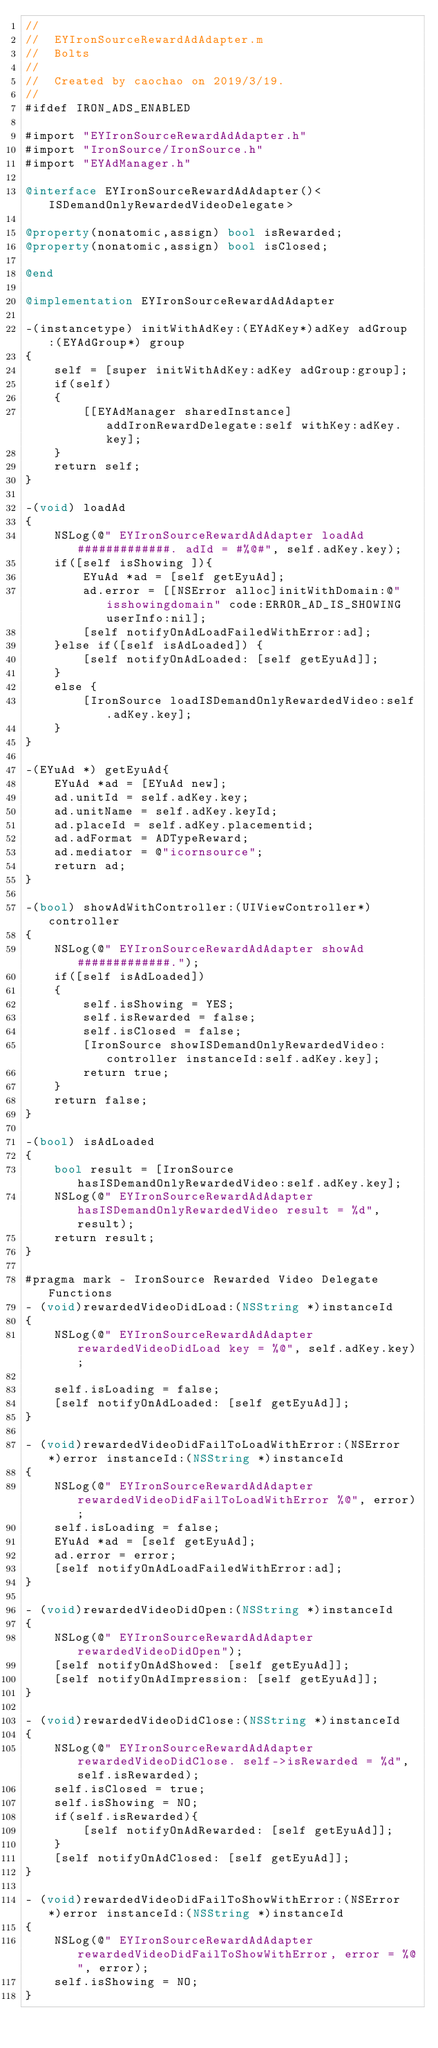<code> <loc_0><loc_0><loc_500><loc_500><_ObjectiveC_>//
//  EYIronSourceRewardAdAdapter.m
//  Bolts
//
//  Created by caochao on 2019/3/19.
//
#ifdef IRON_ADS_ENABLED

#import "EYIronSourceRewardAdAdapter.h"
#import "IronSource/IronSource.h"
#import "EYAdManager.h"

@interface EYIronSourceRewardAdAdapter()<ISDemandOnlyRewardedVideoDelegate>

@property(nonatomic,assign) bool isRewarded;
@property(nonatomic,assign) bool isClosed;

@end

@implementation EYIronSourceRewardAdAdapter

-(instancetype) initWithAdKey:(EYAdKey*)adKey adGroup:(EYAdGroup*) group
{
    self = [super initWithAdKey:adKey adGroup:group];
    if(self)
    {
        [[EYAdManager sharedInstance] addIronRewardDelegate:self withKey:adKey.key];
    }
    return self;
}

-(void) loadAd
{
    NSLog(@" EYIronSourceRewardAdAdapter loadAd #############. adId = #%@#", self.adKey.key);
    if([self isShowing ]){
        EYuAd *ad = [self getEyuAd];
        ad.error = [[NSError alloc]initWithDomain:@"isshowingdomain" code:ERROR_AD_IS_SHOWING userInfo:nil];
        [self notifyOnAdLoadFailedWithError:ad];
    }else if([self isAdLoaded]) {
        [self notifyOnAdLoaded: [self getEyuAd]];
    }
    else {
        [IronSource loadISDemandOnlyRewardedVideo:self.adKey.key];
    }
}

-(EYuAd *) getEyuAd{
    EYuAd *ad = [EYuAd new];
    ad.unitId = self.adKey.key;
    ad.unitName = self.adKey.keyId;
    ad.placeId = self.adKey.placementid;
    ad.adFormat = ADTypeReward;
    ad.mediator = @"icornsource";
    return ad;
}

-(bool) showAdWithController:(UIViewController*) controller
{
    NSLog(@" EYIronSourceRewardAdAdapter showAd #############.");
    if([self isAdLoaded])
    {
        self.isShowing = YES;
        self.isRewarded = false;
        self.isClosed = false;
        [IronSource showISDemandOnlyRewardedVideo:controller instanceId:self.adKey.key];
        return true;
    }
    return false;
}

-(bool) isAdLoaded
{
    bool result = [IronSource hasISDemandOnlyRewardedVideo:self.adKey.key];
    NSLog(@" EYIronSourceRewardAdAdapter hasISDemandOnlyRewardedVideo result = %d",result);
    return result;
}

#pragma mark - IronSource Rewarded Video Delegate Functions
- (void)rewardedVideoDidLoad:(NSString *)instanceId
{
    NSLog(@" EYIronSourceRewardAdAdapter rewardedVideoDidLoad key = %@", self.adKey.key);

    self.isLoading = false;
    [self notifyOnAdLoaded: [self getEyuAd]];
}

- (void)rewardedVideoDidFailToLoadWithError:(NSError *)error instanceId:(NSString *)instanceId
{
    NSLog(@" EYIronSourceRewardAdAdapter rewardedVideoDidFailToLoadWithError %@", error);
    self.isLoading = false;
    EYuAd *ad = [self getEyuAd];
    ad.error = error;
    [self notifyOnAdLoadFailedWithError:ad];
}

- (void)rewardedVideoDidOpen:(NSString *)instanceId
{
    NSLog(@" EYIronSourceRewardAdAdapter rewardedVideoDidOpen");
    [self notifyOnAdShowed: [self getEyuAd]];
    [self notifyOnAdImpression: [self getEyuAd]];
}

- (void)rewardedVideoDidClose:(NSString *)instanceId
{
    NSLog(@" EYIronSourceRewardAdAdapter rewardedVideoDidClose. self->isRewarded = %d", self.isRewarded);
    self.isClosed = true;
    self.isShowing = NO;
    if(self.isRewarded){
        [self notifyOnAdRewarded: [self getEyuAd]];
    }
    [self notifyOnAdClosed: [self getEyuAd]];
}

- (void)rewardedVideoDidFailToShowWithError:(NSError *)error instanceId:(NSString *)instanceId
{
    NSLog(@" EYIronSourceRewardAdAdapter rewardedVideoDidFailToShowWithError, error = %@", error);
    self.isShowing = NO;
}
</code> 